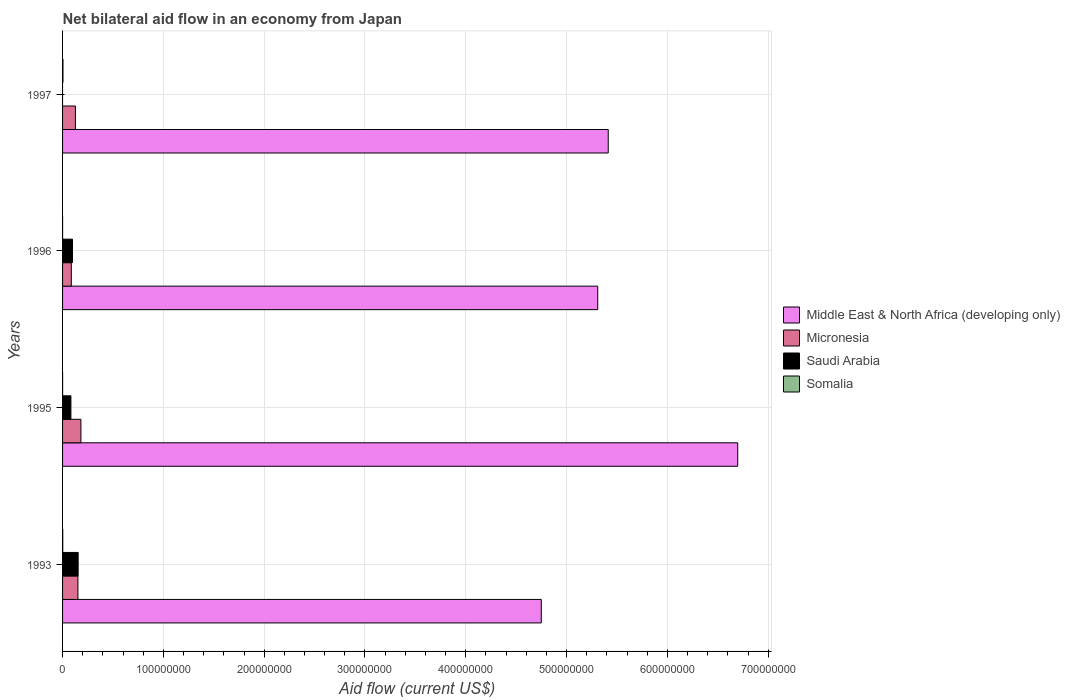How many different coloured bars are there?
Offer a terse response. 4. How many groups of bars are there?
Provide a short and direct response. 4. Are the number of bars on each tick of the Y-axis equal?
Offer a very short reply. No. How many bars are there on the 2nd tick from the top?
Offer a terse response. 4. In how many cases, is the number of bars for a given year not equal to the number of legend labels?
Your answer should be very brief. 1. What is the net bilateral aid flow in Middle East & North Africa (developing only) in 1997?
Offer a very short reply. 5.41e+08. Across all years, what is the maximum net bilateral aid flow in Middle East & North Africa (developing only)?
Keep it short and to the point. 6.70e+08. What is the total net bilateral aid flow in Middle East & North Africa (developing only) in the graph?
Your answer should be compact. 2.22e+09. What is the difference between the net bilateral aid flow in Saudi Arabia in 1993 and that in 1996?
Offer a terse response. 5.62e+06. What is the difference between the net bilateral aid flow in Saudi Arabia in 1996 and the net bilateral aid flow in Micronesia in 1997?
Ensure brevity in your answer.  -2.91e+06. What is the average net bilateral aid flow in Saudi Arabia per year?
Provide a succinct answer. 8.40e+06. In the year 1996, what is the difference between the net bilateral aid flow in Micronesia and net bilateral aid flow in Middle East & North Africa (developing only)?
Provide a succinct answer. -5.22e+08. What is the ratio of the net bilateral aid flow in Middle East & North Africa (developing only) in 1993 to that in 1997?
Offer a very short reply. 0.88. What is the difference between the highest and the second highest net bilateral aid flow in Micronesia?
Your answer should be compact. 2.98e+06. What is the difference between the highest and the lowest net bilateral aid flow in Micronesia?
Your response must be concise. 9.54e+06. Is the sum of the net bilateral aid flow in Middle East & North Africa (developing only) in 1993 and 1996 greater than the maximum net bilateral aid flow in Somalia across all years?
Keep it short and to the point. Yes. Does the graph contain any zero values?
Your answer should be compact. Yes. Does the graph contain grids?
Give a very brief answer. Yes. Where does the legend appear in the graph?
Your response must be concise. Center right. How many legend labels are there?
Provide a short and direct response. 4. How are the legend labels stacked?
Ensure brevity in your answer.  Vertical. What is the title of the graph?
Provide a succinct answer. Net bilateral aid flow in an economy from Japan. Does "Brazil" appear as one of the legend labels in the graph?
Offer a very short reply. No. What is the label or title of the X-axis?
Your answer should be compact. Aid flow (current US$). What is the Aid flow (current US$) in Middle East & North Africa (developing only) in 1993?
Provide a short and direct response. 4.75e+08. What is the Aid flow (current US$) in Micronesia in 1993?
Keep it short and to the point. 1.52e+07. What is the Aid flow (current US$) in Saudi Arabia in 1993?
Give a very brief answer. 1.55e+07. What is the Aid flow (current US$) of Somalia in 1993?
Provide a short and direct response. 1.80e+05. What is the Aid flow (current US$) of Middle East & North Africa (developing only) in 1995?
Give a very brief answer. 6.70e+08. What is the Aid flow (current US$) of Micronesia in 1995?
Provide a short and direct response. 1.82e+07. What is the Aid flow (current US$) of Saudi Arabia in 1995?
Keep it short and to the point. 8.28e+06. What is the Aid flow (current US$) of Middle East & North Africa (developing only) in 1996?
Your response must be concise. 5.31e+08. What is the Aid flow (current US$) in Micronesia in 1996?
Your response must be concise. 8.67e+06. What is the Aid flow (current US$) in Saudi Arabia in 1996?
Ensure brevity in your answer.  9.85e+06. What is the Aid flow (current US$) in Middle East & North Africa (developing only) in 1997?
Provide a succinct answer. 5.41e+08. What is the Aid flow (current US$) of Micronesia in 1997?
Provide a short and direct response. 1.28e+07. What is the Aid flow (current US$) of Somalia in 1997?
Your response must be concise. 4.00e+05. Across all years, what is the maximum Aid flow (current US$) in Middle East & North Africa (developing only)?
Offer a terse response. 6.70e+08. Across all years, what is the maximum Aid flow (current US$) in Micronesia?
Offer a very short reply. 1.82e+07. Across all years, what is the maximum Aid flow (current US$) of Saudi Arabia?
Provide a succinct answer. 1.55e+07. Across all years, what is the maximum Aid flow (current US$) in Somalia?
Give a very brief answer. 4.00e+05. Across all years, what is the minimum Aid flow (current US$) of Middle East & North Africa (developing only)?
Offer a very short reply. 4.75e+08. Across all years, what is the minimum Aid flow (current US$) in Micronesia?
Make the answer very short. 8.67e+06. Across all years, what is the minimum Aid flow (current US$) of Saudi Arabia?
Offer a terse response. 0. What is the total Aid flow (current US$) of Middle East & North Africa (developing only) in the graph?
Give a very brief answer. 2.22e+09. What is the total Aid flow (current US$) in Micronesia in the graph?
Keep it short and to the point. 5.49e+07. What is the total Aid flow (current US$) in Saudi Arabia in the graph?
Make the answer very short. 3.36e+07. What is the total Aid flow (current US$) of Somalia in the graph?
Offer a very short reply. 6.10e+05. What is the difference between the Aid flow (current US$) of Middle East & North Africa (developing only) in 1993 and that in 1995?
Make the answer very short. -1.95e+08. What is the difference between the Aid flow (current US$) of Micronesia in 1993 and that in 1995?
Offer a very short reply. -2.98e+06. What is the difference between the Aid flow (current US$) in Saudi Arabia in 1993 and that in 1995?
Provide a succinct answer. 7.19e+06. What is the difference between the Aid flow (current US$) in Middle East & North Africa (developing only) in 1993 and that in 1996?
Provide a succinct answer. -5.60e+07. What is the difference between the Aid flow (current US$) in Micronesia in 1993 and that in 1996?
Your answer should be compact. 6.56e+06. What is the difference between the Aid flow (current US$) of Saudi Arabia in 1993 and that in 1996?
Your response must be concise. 5.62e+06. What is the difference between the Aid flow (current US$) of Somalia in 1993 and that in 1996?
Keep it short and to the point. 1.70e+05. What is the difference between the Aid flow (current US$) in Middle East & North Africa (developing only) in 1993 and that in 1997?
Keep it short and to the point. -6.64e+07. What is the difference between the Aid flow (current US$) of Micronesia in 1993 and that in 1997?
Make the answer very short. 2.47e+06. What is the difference between the Aid flow (current US$) of Middle East & North Africa (developing only) in 1995 and that in 1996?
Provide a succinct answer. 1.39e+08. What is the difference between the Aid flow (current US$) in Micronesia in 1995 and that in 1996?
Your answer should be very brief. 9.54e+06. What is the difference between the Aid flow (current US$) of Saudi Arabia in 1995 and that in 1996?
Make the answer very short. -1.57e+06. What is the difference between the Aid flow (current US$) of Middle East & North Africa (developing only) in 1995 and that in 1997?
Your answer should be very brief. 1.28e+08. What is the difference between the Aid flow (current US$) of Micronesia in 1995 and that in 1997?
Offer a very short reply. 5.45e+06. What is the difference between the Aid flow (current US$) in Somalia in 1995 and that in 1997?
Keep it short and to the point. -3.80e+05. What is the difference between the Aid flow (current US$) in Middle East & North Africa (developing only) in 1996 and that in 1997?
Make the answer very short. -1.04e+07. What is the difference between the Aid flow (current US$) in Micronesia in 1996 and that in 1997?
Your answer should be very brief. -4.09e+06. What is the difference between the Aid flow (current US$) in Somalia in 1996 and that in 1997?
Your response must be concise. -3.90e+05. What is the difference between the Aid flow (current US$) of Middle East & North Africa (developing only) in 1993 and the Aid flow (current US$) of Micronesia in 1995?
Ensure brevity in your answer.  4.57e+08. What is the difference between the Aid flow (current US$) in Middle East & North Africa (developing only) in 1993 and the Aid flow (current US$) in Saudi Arabia in 1995?
Provide a succinct answer. 4.67e+08. What is the difference between the Aid flow (current US$) in Middle East & North Africa (developing only) in 1993 and the Aid flow (current US$) in Somalia in 1995?
Provide a short and direct response. 4.75e+08. What is the difference between the Aid flow (current US$) of Micronesia in 1993 and the Aid flow (current US$) of Saudi Arabia in 1995?
Provide a short and direct response. 6.95e+06. What is the difference between the Aid flow (current US$) of Micronesia in 1993 and the Aid flow (current US$) of Somalia in 1995?
Your answer should be compact. 1.52e+07. What is the difference between the Aid flow (current US$) in Saudi Arabia in 1993 and the Aid flow (current US$) in Somalia in 1995?
Provide a short and direct response. 1.54e+07. What is the difference between the Aid flow (current US$) in Middle East & North Africa (developing only) in 1993 and the Aid flow (current US$) in Micronesia in 1996?
Offer a very short reply. 4.66e+08. What is the difference between the Aid flow (current US$) in Middle East & North Africa (developing only) in 1993 and the Aid flow (current US$) in Saudi Arabia in 1996?
Your answer should be very brief. 4.65e+08. What is the difference between the Aid flow (current US$) in Middle East & North Africa (developing only) in 1993 and the Aid flow (current US$) in Somalia in 1996?
Make the answer very short. 4.75e+08. What is the difference between the Aid flow (current US$) of Micronesia in 1993 and the Aid flow (current US$) of Saudi Arabia in 1996?
Your answer should be very brief. 5.38e+06. What is the difference between the Aid flow (current US$) in Micronesia in 1993 and the Aid flow (current US$) in Somalia in 1996?
Your answer should be very brief. 1.52e+07. What is the difference between the Aid flow (current US$) in Saudi Arabia in 1993 and the Aid flow (current US$) in Somalia in 1996?
Offer a very short reply. 1.55e+07. What is the difference between the Aid flow (current US$) in Middle East & North Africa (developing only) in 1993 and the Aid flow (current US$) in Micronesia in 1997?
Offer a terse response. 4.62e+08. What is the difference between the Aid flow (current US$) of Middle East & North Africa (developing only) in 1993 and the Aid flow (current US$) of Somalia in 1997?
Your answer should be very brief. 4.74e+08. What is the difference between the Aid flow (current US$) of Micronesia in 1993 and the Aid flow (current US$) of Somalia in 1997?
Offer a very short reply. 1.48e+07. What is the difference between the Aid flow (current US$) of Saudi Arabia in 1993 and the Aid flow (current US$) of Somalia in 1997?
Keep it short and to the point. 1.51e+07. What is the difference between the Aid flow (current US$) of Middle East & North Africa (developing only) in 1995 and the Aid flow (current US$) of Micronesia in 1996?
Give a very brief answer. 6.61e+08. What is the difference between the Aid flow (current US$) of Middle East & North Africa (developing only) in 1995 and the Aid flow (current US$) of Saudi Arabia in 1996?
Provide a short and direct response. 6.60e+08. What is the difference between the Aid flow (current US$) in Middle East & North Africa (developing only) in 1995 and the Aid flow (current US$) in Somalia in 1996?
Your response must be concise. 6.70e+08. What is the difference between the Aid flow (current US$) of Micronesia in 1995 and the Aid flow (current US$) of Saudi Arabia in 1996?
Ensure brevity in your answer.  8.36e+06. What is the difference between the Aid flow (current US$) in Micronesia in 1995 and the Aid flow (current US$) in Somalia in 1996?
Make the answer very short. 1.82e+07. What is the difference between the Aid flow (current US$) in Saudi Arabia in 1995 and the Aid flow (current US$) in Somalia in 1996?
Provide a succinct answer. 8.27e+06. What is the difference between the Aid flow (current US$) in Middle East & North Africa (developing only) in 1995 and the Aid flow (current US$) in Micronesia in 1997?
Your answer should be very brief. 6.57e+08. What is the difference between the Aid flow (current US$) of Middle East & North Africa (developing only) in 1995 and the Aid flow (current US$) of Somalia in 1997?
Offer a terse response. 6.69e+08. What is the difference between the Aid flow (current US$) in Micronesia in 1995 and the Aid flow (current US$) in Somalia in 1997?
Your response must be concise. 1.78e+07. What is the difference between the Aid flow (current US$) in Saudi Arabia in 1995 and the Aid flow (current US$) in Somalia in 1997?
Offer a terse response. 7.88e+06. What is the difference between the Aid flow (current US$) of Middle East & North Africa (developing only) in 1996 and the Aid flow (current US$) of Micronesia in 1997?
Offer a terse response. 5.18e+08. What is the difference between the Aid flow (current US$) of Middle East & North Africa (developing only) in 1996 and the Aid flow (current US$) of Somalia in 1997?
Keep it short and to the point. 5.30e+08. What is the difference between the Aid flow (current US$) of Micronesia in 1996 and the Aid flow (current US$) of Somalia in 1997?
Ensure brevity in your answer.  8.27e+06. What is the difference between the Aid flow (current US$) in Saudi Arabia in 1996 and the Aid flow (current US$) in Somalia in 1997?
Keep it short and to the point. 9.45e+06. What is the average Aid flow (current US$) of Middle East & North Africa (developing only) per year?
Your response must be concise. 5.54e+08. What is the average Aid flow (current US$) of Micronesia per year?
Keep it short and to the point. 1.37e+07. What is the average Aid flow (current US$) of Saudi Arabia per year?
Provide a short and direct response. 8.40e+06. What is the average Aid flow (current US$) in Somalia per year?
Ensure brevity in your answer.  1.52e+05. In the year 1993, what is the difference between the Aid flow (current US$) of Middle East & North Africa (developing only) and Aid flow (current US$) of Micronesia?
Your answer should be compact. 4.60e+08. In the year 1993, what is the difference between the Aid flow (current US$) in Middle East & North Africa (developing only) and Aid flow (current US$) in Saudi Arabia?
Your answer should be compact. 4.59e+08. In the year 1993, what is the difference between the Aid flow (current US$) in Middle East & North Africa (developing only) and Aid flow (current US$) in Somalia?
Offer a very short reply. 4.75e+08. In the year 1993, what is the difference between the Aid flow (current US$) of Micronesia and Aid flow (current US$) of Somalia?
Provide a short and direct response. 1.50e+07. In the year 1993, what is the difference between the Aid flow (current US$) of Saudi Arabia and Aid flow (current US$) of Somalia?
Provide a succinct answer. 1.53e+07. In the year 1995, what is the difference between the Aid flow (current US$) in Middle East & North Africa (developing only) and Aid flow (current US$) in Micronesia?
Offer a very short reply. 6.52e+08. In the year 1995, what is the difference between the Aid flow (current US$) in Middle East & North Africa (developing only) and Aid flow (current US$) in Saudi Arabia?
Give a very brief answer. 6.61e+08. In the year 1995, what is the difference between the Aid flow (current US$) in Middle East & North Africa (developing only) and Aid flow (current US$) in Somalia?
Ensure brevity in your answer.  6.70e+08. In the year 1995, what is the difference between the Aid flow (current US$) of Micronesia and Aid flow (current US$) of Saudi Arabia?
Your answer should be very brief. 9.93e+06. In the year 1995, what is the difference between the Aid flow (current US$) in Micronesia and Aid flow (current US$) in Somalia?
Your answer should be very brief. 1.82e+07. In the year 1995, what is the difference between the Aid flow (current US$) of Saudi Arabia and Aid flow (current US$) of Somalia?
Make the answer very short. 8.26e+06. In the year 1996, what is the difference between the Aid flow (current US$) in Middle East & North Africa (developing only) and Aid flow (current US$) in Micronesia?
Your answer should be compact. 5.22e+08. In the year 1996, what is the difference between the Aid flow (current US$) of Middle East & North Africa (developing only) and Aid flow (current US$) of Saudi Arabia?
Keep it short and to the point. 5.21e+08. In the year 1996, what is the difference between the Aid flow (current US$) in Middle East & North Africa (developing only) and Aid flow (current US$) in Somalia?
Offer a very short reply. 5.31e+08. In the year 1996, what is the difference between the Aid flow (current US$) in Micronesia and Aid flow (current US$) in Saudi Arabia?
Offer a very short reply. -1.18e+06. In the year 1996, what is the difference between the Aid flow (current US$) in Micronesia and Aid flow (current US$) in Somalia?
Ensure brevity in your answer.  8.66e+06. In the year 1996, what is the difference between the Aid flow (current US$) of Saudi Arabia and Aid flow (current US$) of Somalia?
Make the answer very short. 9.84e+06. In the year 1997, what is the difference between the Aid flow (current US$) in Middle East & North Africa (developing only) and Aid flow (current US$) in Micronesia?
Your response must be concise. 5.29e+08. In the year 1997, what is the difference between the Aid flow (current US$) of Middle East & North Africa (developing only) and Aid flow (current US$) of Somalia?
Offer a very short reply. 5.41e+08. In the year 1997, what is the difference between the Aid flow (current US$) of Micronesia and Aid flow (current US$) of Somalia?
Offer a terse response. 1.24e+07. What is the ratio of the Aid flow (current US$) of Middle East & North Africa (developing only) in 1993 to that in 1995?
Give a very brief answer. 0.71. What is the ratio of the Aid flow (current US$) of Micronesia in 1993 to that in 1995?
Offer a terse response. 0.84. What is the ratio of the Aid flow (current US$) of Saudi Arabia in 1993 to that in 1995?
Provide a short and direct response. 1.87. What is the ratio of the Aid flow (current US$) in Somalia in 1993 to that in 1995?
Offer a very short reply. 9. What is the ratio of the Aid flow (current US$) in Middle East & North Africa (developing only) in 1993 to that in 1996?
Your answer should be very brief. 0.89. What is the ratio of the Aid flow (current US$) in Micronesia in 1993 to that in 1996?
Provide a succinct answer. 1.76. What is the ratio of the Aid flow (current US$) in Saudi Arabia in 1993 to that in 1996?
Make the answer very short. 1.57. What is the ratio of the Aid flow (current US$) of Somalia in 1993 to that in 1996?
Ensure brevity in your answer.  18. What is the ratio of the Aid flow (current US$) in Middle East & North Africa (developing only) in 1993 to that in 1997?
Your answer should be compact. 0.88. What is the ratio of the Aid flow (current US$) in Micronesia in 1993 to that in 1997?
Provide a short and direct response. 1.19. What is the ratio of the Aid flow (current US$) of Somalia in 1993 to that in 1997?
Provide a succinct answer. 0.45. What is the ratio of the Aid flow (current US$) in Middle East & North Africa (developing only) in 1995 to that in 1996?
Make the answer very short. 1.26. What is the ratio of the Aid flow (current US$) in Micronesia in 1995 to that in 1996?
Keep it short and to the point. 2.1. What is the ratio of the Aid flow (current US$) of Saudi Arabia in 1995 to that in 1996?
Offer a very short reply. 0.84. What is the ratio of the Aid flow (current US$) in Middle East & North Africa (developing only) in 1995 to that in 1997?
Make the answer very short. 1.24. What is the ratio of the Aid flow (current US$) in Micronesia in 1995 to that in 1997?
Keep it short and to the point. 1.43. What is the ratio of the Aid flow (current US$) in Middle East & North Africa (developing only) in 1996 to that in 1997?
Give a very brief answer. 0.98. What is the ratio of the Aid flow (current US$) in Micronesia in 1996 to that in 1997?
Provide a succinct answer. 0.68. What is the ratio of the Aid flow (current US$) of Somalia in 1996 to that in 1997?
Ensure brevity in your answer.  0.03. What is the difference between the highest and the second highest Aid flow (current US$) in Middle East & North Africa (developing only)?
Give a very brief answer. 1.28e+08. What is the difference between the highest and the second highest Aid flow (current US$) in Micronesia?
Ensure brevity in your answer.  2.98e+06. What is the difference between the highest and the second highest Aid flow (current US$) in Saudi Arabia?
Your answer should be compact. 5.62e+06. What is the difference between the highest and the second highest Aid flow (current US$) in Somalia?
Your response must be concise. 2.20e+05. What is the difference between the highest and the lowest Aid flow (current US$) in Middle East & North Africa (developing only)?
Your answer should be compact. 1.95e+08. What is the difference between the highest and the lowest Aid flow (current US$) in Micronesia?
Provide a succinct answer. 9.54e+06. What is the difference between the highest and the lowest Aid flow (current US$) of Saudi Arabia?
Your response must be concise. 1.55e+07. What is the difference between the highest and the lowest Aid flow (current US$) of Somalia?
Make the answer very short. 3.90e+05. 